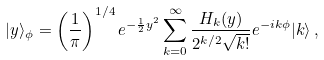Convert formula to latex. <formula><loc_0><loc_0><loc_500><loc_500>| y \rangle _ { \phi } = \left ( \frac { 1 } { \pi } \right ) ^ { 1 / 4 } e ^ { - \frac { 1 } { 2 } y ^ { 2 } } \sum _ { k = 0 } ^ { \infty } \frac { H _ { k } ( y ) } { 2 ^ { k / 2 } \sqrt { k ! } } e ^ { - i k \phi } | k \rangle \, ,</formula> 